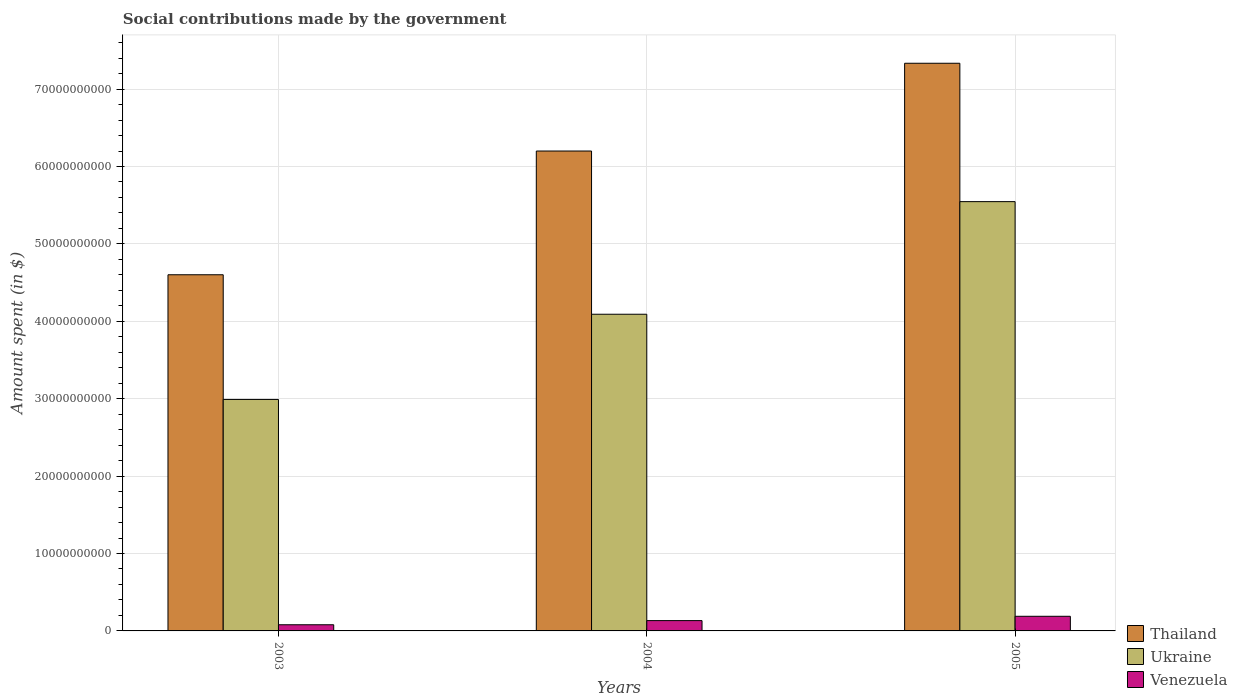How many different coloured bars are there?
Make the answer very short. 3. How many groups of bars are there?
Your response must be concise. 3. Are the number of bars per tick equal to the number of legend labels?
Offer a terse response. Yes. Are the number of bars on each tick of the X-axis equal?
Your answer should be very brief. Yes. In how many cases, is the number of bars for a given year not equal to the number of legend labels?
Provide a short and direct response. 0. What is the amount spent on social contributions in Venezuela in 2004?
Your response must be concise. 1.33e+09. Across all years, what is the maximum amount spent on social contributions in Ukraine?
Provide a succinct answer. 5.55e+1. Across all years, what is the minimum amount spent on social contributions in Ukraine?
Offer a terse response. 2.99e+1. In which year was the amount spent on social contributions in Ukraine maximum?
Give a very brief answer. 2005. In which year was the amount spent on social contributions in Venezuela minimum?
Offer a terse response. 2003. What is the total amount spent on social contributions in Thailand in the graph?
Your answer should be very brief. 1.81e+11. What is the difference between the amount spent on social contributions in Thailand in 2003 and that in 2004?
Make the answer very short. -1.60e+1. What is the difference between the amount spent on social contributions in Ukraine in 2003 and the amount spent on social contributions in Thailand in 2005?
Offer a terse response. -4.34e+1. What is the average amount spent on social contributions in Ukraine per year?
Your answer should be compact. 4.21e+1. In the year 2004, what is the difference between the amount spent on social contributions in Thailand and amount spent on social contributions in Venezuela?
Make the answer very short. 6.07e+1. In how many years, is the amount spent on social contributions in Venezuela greater than 40000000000 $?
Provide a succinct answer. 0. What is the ratio of the amount spent on social contributions in Venezuela in 2003 to that in 2004?
Your answer should be compact. 0.6. Is the amount spent on social contributions in Ukraine in 2003 less than that in 2004?
Your response must be concise. Yes. Is the difference between the amount spent on social contributions in Thailand in 2003 and 2004 greater than the difference between the amount spent on social contributions in Venezuela in 2003 and 2004?
Provide a succinct answer. No. What is the difference between the highest and the second highest amount spent on social contributions in Ukraine?
Offer a very short reply. 1.45e+1. What is the difference between the highest and the lowest amount spent on social contributions in Ukraine?
Offer a terse response. 2.56e+1. What does the 2nd bar from the left in 2003 represents?
Your answer should be compact. Ukraine. What does the 1st bar from the right in 2005 represents?
Offer a terse response. Venezuela. Is it the case that in every year, the sum of the amount spent on social contributions in Thailand and amount spent on social contributions in Venezuela is greater than the amount spent on social contributions in Ukraine?
Ensure brevity in your answer.  Yes. How many bars are there?
Offer a terse response. 9. Are all the bars in the graph horizontal?
Offer a very short reply. No. What is the difference between two consecutive major ticks on the Y-axis?
Ensure brevity in your answer.  1.00e+1. Are the values on the major ticks of Y-axis written in scientific E-notation?
Make the answer very short. No. Does the graph contain any zero values?
Keep it short and to the point. No. Does the graph contain grids?
Keep it short and to the point. Yes. What is the title of the graph?
Your answer should be very brief. Social contributions made by the government. Does "Morocco" appear as one of the legend labels in the graph?
Provide a succinct answer. No. What is the label or title of the X-axis?
Provide a succinct answer. Years. What is the label or title of the Y-axis?
Ensure brevity in your answer.  Amount spent (in $). What is the Amount spent (in $) in Thailand in 2003?
Your answer should be very brief. 4.60e+1. What is the Amount spent (in $) in Ukraine in 2003?
Ensure brevity in your answer.  2.99e+1. What is the Amount spent (in $) in Venezuela in 2003?
Give a very brief answer. 7.97e+08. What is the Amount spent (in $) of Thailand in 2004?
Ensure brevity in your answer.  6.20e+1. What is the Amount spent (in $) of Ukraine in 2004?
Provide a succinct answer. 4.09e+1. What is the Amount spent (in $) in Venezuela in 2004?
Provide a short and direct response. 1.33e+09. What is the Amount spent (in $) in Thailand in 2005?
Keep it short and to the point. 7.33e+1. What is the Amount spent (in $) in Ukraine in 2005?
Make the answer very short. 5.55e+1. What is the Amount spent (in $) of Venezuela in 2005?
Provide a short and direct response. 1.89e+09. Across all years, what is the maximum Amount spent (in $) of Thailand?
Ensure brevity in your answer.  7.33e+1. Across all years, what is the maximum Amount spent (in $) of Ukraine?
Provide a short and direct response. 5.55e+1. Across all years, what is the maximum Amount spent (in $) of Venezuela?
Give a very brief answer. 1.89e+09. Across all years, what is the minimum Amount spent (in $) of Thailand?
Make the answer very short. 4.60e+1. Across all years, what is the minimum Amount spent (in $) of Ukraine?
Your answer should be very brief. 2.99e+1. Across all years, what is the minimum Amount spent (in $) in Venezuela?
Your answer should be very brief. 7.97e+08. What is the total Amount spent (in $) of Thailand in the graph?
Give a very brief answer. 1.81e+11. What is the total Amount spent (in $) of Ukraine in the graph?
Your answer should be very brief. 1.26e+11. What is the total Amount spent (in $) in Venezuela in the graph?
Provide a succinct answer. 4.02e+09. What is the difference between the Amount spent (in $) of Thailand in 2003 and that in 2004?
Offer a very short reply. -1.60e+1. What is the difference between the Amount spent (in $) of Ukraine in 2003 and that in 2004?
Provide a short and direct response. -1.10e+1. What is the difference between the Amount spent (in $) of Venezuela in 2003 and that in 2004?
Provide a succinct answer. -5.37e+08. What is the difference between the Amount spent (in $) in Thailand in 2003 and that in 2005?
Give a very brief answer. -2.73e+1. What is the difference between the Amount spent (in $) of Ukraine in 2003 and that in 2005?
Ensure brevity in your answer.  -2.56e+1. What is the difference between the Amount spent (in $) of Venezuela in 2003 and that in 2005?
Offer a terse response. -1.09e+09. What is the difference between the Amount spent (in $) in Thailand in 2004 and that in 2005?
Your answer should be very brief. -1.13e+1. What is the difference between the Amount spent (in $) of Ukraine in 2004 and that in 2005?
Offer a very short reply. -1.45e+1. What is the difference between the Amount spent (in $) of Venezuela in 2004 and that in 2005?
Ensure brevity in your answer.  -5.56e+08. What is the difference between the Amount spent (in $) in Thailand in 2003 and the Amount spent (in $) in Ukraine in 2004?
Give a very brief answer. 5.10e+09. What is the difference between the Amount spent (in $) of Thailand in 2003 and the Amount spent (in $) of Venezuela in 2004?
Make the answer very short. 4.47e+1. What is the difference between the Amount spent (in $) in Ukraine in 2003 and the Amount spent (in $) in Venezuela in 2004?
Make the answer very short. 2.86e+1. What is the difference between the Amount spent (in $) of Thailand in 2003 and the Amount spent (in $) of Ukraine in 2005?
Make the answer very short. -9.45e+09. What is the difference between the Amount spent (in $) in Thailand in 2003 and the Amount spent (in $) in Venezuela in 2005?
Your answer should be compact. 4.41e+1. What is the difference between the Amount spent (in $) of Ukraine in 2003 and the Amount spent (in $) of Venezuela in 2005?
Offer a very short reply. 2.80e+1. What is the difference between the Amount spent (in $) of Thailand in 2004 and the Amount spent (in $) of Ukraine in 2005?
Offer a terse response. 6.54e+09. What is the difference between the Amount spent (in $) of Thailand in 2004 and the Amount spent (in $) of Venezuela in 2005?
Your response must be concise. 6.01e+1. What is the difference between the Amount spent (in $) of Ukraine in 2004 and the Amount spent (in $) of Venezuela in 2005?
Ensure brevity in your answer.  3.90e+1. What is the average Amount spent (in $) of Thailand per year?
Provide a short and direct response. 6.04e+1. What is the average Amount spent (in $) in Ukraine per year?
Provide a succinct answer. 4.21e+1. What is the average Amount spent (in $) in Venezuela per year?
Provide a short and direct response. 1.34e+09. In the year 2003, what is the difference between the Amount spent (in $) of Thailand and Amount spent (in $) of Ukraine?
Ensure brevity in your answer.  1.61e+1. In the year 2003, what is the difference between the Amount spent (in $) of Thailand and Amount spent (in $) of Venezuela?
Ensure brevity in your answer.  4.52e+1. In the year 2003, what is the difference between the Amount spent (in $) of Ukraine and Amount spent (in $) of Venezuela?
Offer a terse response. 2.91e+1. In the year 2004, what is the difference between the Amount spent (in $) in Thailand and Amount spent (in $) in Ukraine?
Provide a succinct answer. 2.11e+1. In the year 2004, what is the difference between the Amount spent (in $) of Thailand and Amount spent (in $) of Venezuela?
Your response must be concise. 6.07e+1. In the year 2004, what is the difference between the Amount spent (in $) in Ukraine and Amount spent (in $) in Venezuela?
Give a very brief answer. 3.96e+1. In the year 2005, what is the difference between the Amount spent (in $) in Thailand and Amount spent (in $) in Ukraine?
Your answer should be compact. 1.79e+1. In the year 2005, what is the difference between the Amount spent (in $) in Thailand and Amount spent (in $) in Venezuela?
Your answer should be very brief. 7.14e+1. In the year 2005, what is the difference between the Amount spent (in $) of Ukraine and Amount spent (in $) of Venezuela?
Your response must be concise. 5.36e+1. What is the ratio of the Amount spent (in $) of Thailand in 2003 to that in 2004?
Ensure brevity in your answer.  0.74. What is the ratio of the Amount spent (in $) in Ukraine in 2003 to that in 2004?
Provide a short and direct response. 0.73. What is the ratio of the Amount spent (in $) of Venezuela in 2003 to that in 2004?
Your response must be concise. 0.6. What is the ratio of the Amount spent (in $) in Thailand in 2003 to that in 2005?
Make the answer very short. 0.63. What is the ratio of the Amount spent (in $) of Ukraine in 2003 to that in 2005?
Keep it short and to the point. 0.54. What is the ratio of the Amount spent (in $) of Venezuela in 2003 to that in 2005?
Offer a very short reply. 0.42. What is the ratio of the Amount spent (in $) in Thailand in 2004 to that in 2005?
Provide a short and direct response. 0.85. What is the ratio of the Amount spent (in $) of Ukraine in 2004 to that in 2005?
Provide a short and direct response. 0.74. What is the ratio of the Amount spent (in $) of Venezuela in 2004 to that in 2005?
Your answer should be very brief. 0.71. What is the difference between the highest and the second highest Amount spent (in $) of Thailand?
Your answer should be compact. 1.13e+1. What is the difference between the highest and the second highest Amount spent (in $) in Ukraine?
Provide a short and direct response. 1.45e+1. What is the difference between the highest and the second highest Amount spent (in $) of Venezuela?
Your response must be concise. 5.56e+08. What is the difference between the highest and the lowest Amount spent (in $) in Thailand?
Make the answer very short. 2.73e+1. What is the difference between the highest and the lowest Amount spent (in $) in Ukraine?
Provide a short and direct response. 2.56e+1. What is the difference between the highest and the lowest Amount spent (in $) in Venezuela?
Your answer should be compact. 1.09e+09. 